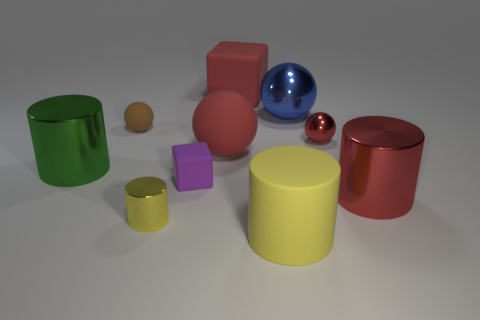If this scene were part of a children's learning game, which concepts could it be used to teach? This colorful assembly could be an excellent resource for a variety of educational themes. For starters, it could be used to teach about colors and shapes, by asking children to identify objects with similar hues or particular geometric forms. Furthermore, the varying sizes and reflectivity of the objects could be leveraged to introduce concepts of comparison and properties of materials, such as which are reflective or matte. Finally, with imagination, it could serve as a prompt for counting exercises or even simple physics lessons like reflections and the behavior of light. 